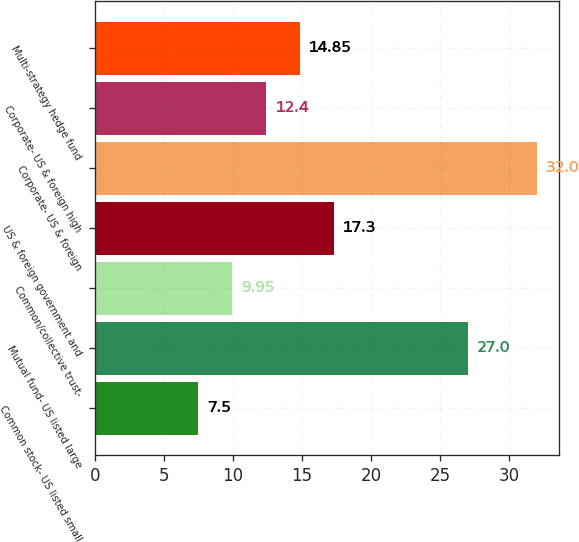Convert chart. <chart><loc_0><loc_0><loc_500><loc_500><bar_chart><fcel>Common stock- US listed small<fcel>Mutual fund- US listed large<fcel>Common/collective trust-<fcel>US & foreign government and<fcel>Corporate- US & foreign<fcel>Corporate- US & foreign high<fcel>Multi-strategy hedge fund<nl><fcel>7.5<fcel>27<fcel>9.95<fcel>17.3<fcel>32<fcel>12.4<fcel>14.85<nl></chart> 